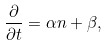Convert formula to latex. <formula><loc_0><loc_0><loc_500><loc_500>\frac { \partial } { \partial t } = \alpha n + \beta ,</formula> 